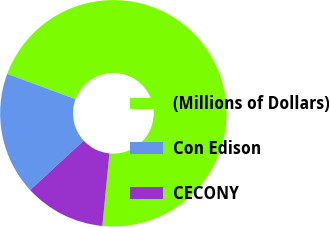Convert chart to OTSL. <chart><loc_0><loc_0><loc_500><loc_500><pie_chart><fcel>(Millions of Dollars)<fcel>Con Edison<fcel>CECONY<nl><fcel>70.9%<fcel>17.52%<fcel>11.59%<nl></chart> 